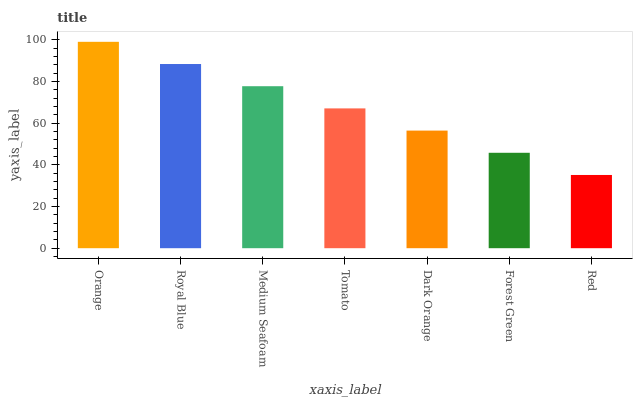Is Royal Blue the minimum?
Answer yes or no. No. Is Royal Blue the maximum?
Answer yes or no. No. Is Orange greater than Royal Blue?
Answer yes or no. Yes. Is Royal Blue less than Orange?
Answer yes or no. Yes. Is Royal Blue greater than Orange?
Answer yes or no. No. Is Orange less than Royal Blue?
Answer yes or no. No. Is Tomato the high median?
Answer yes or no. Yes. Is Tomato the low median?
Answer yes or no. Yes. Is Royal Blue the high median?
Answer yes or no. No. Is Orange the low median?
Answer yes or no. No. 